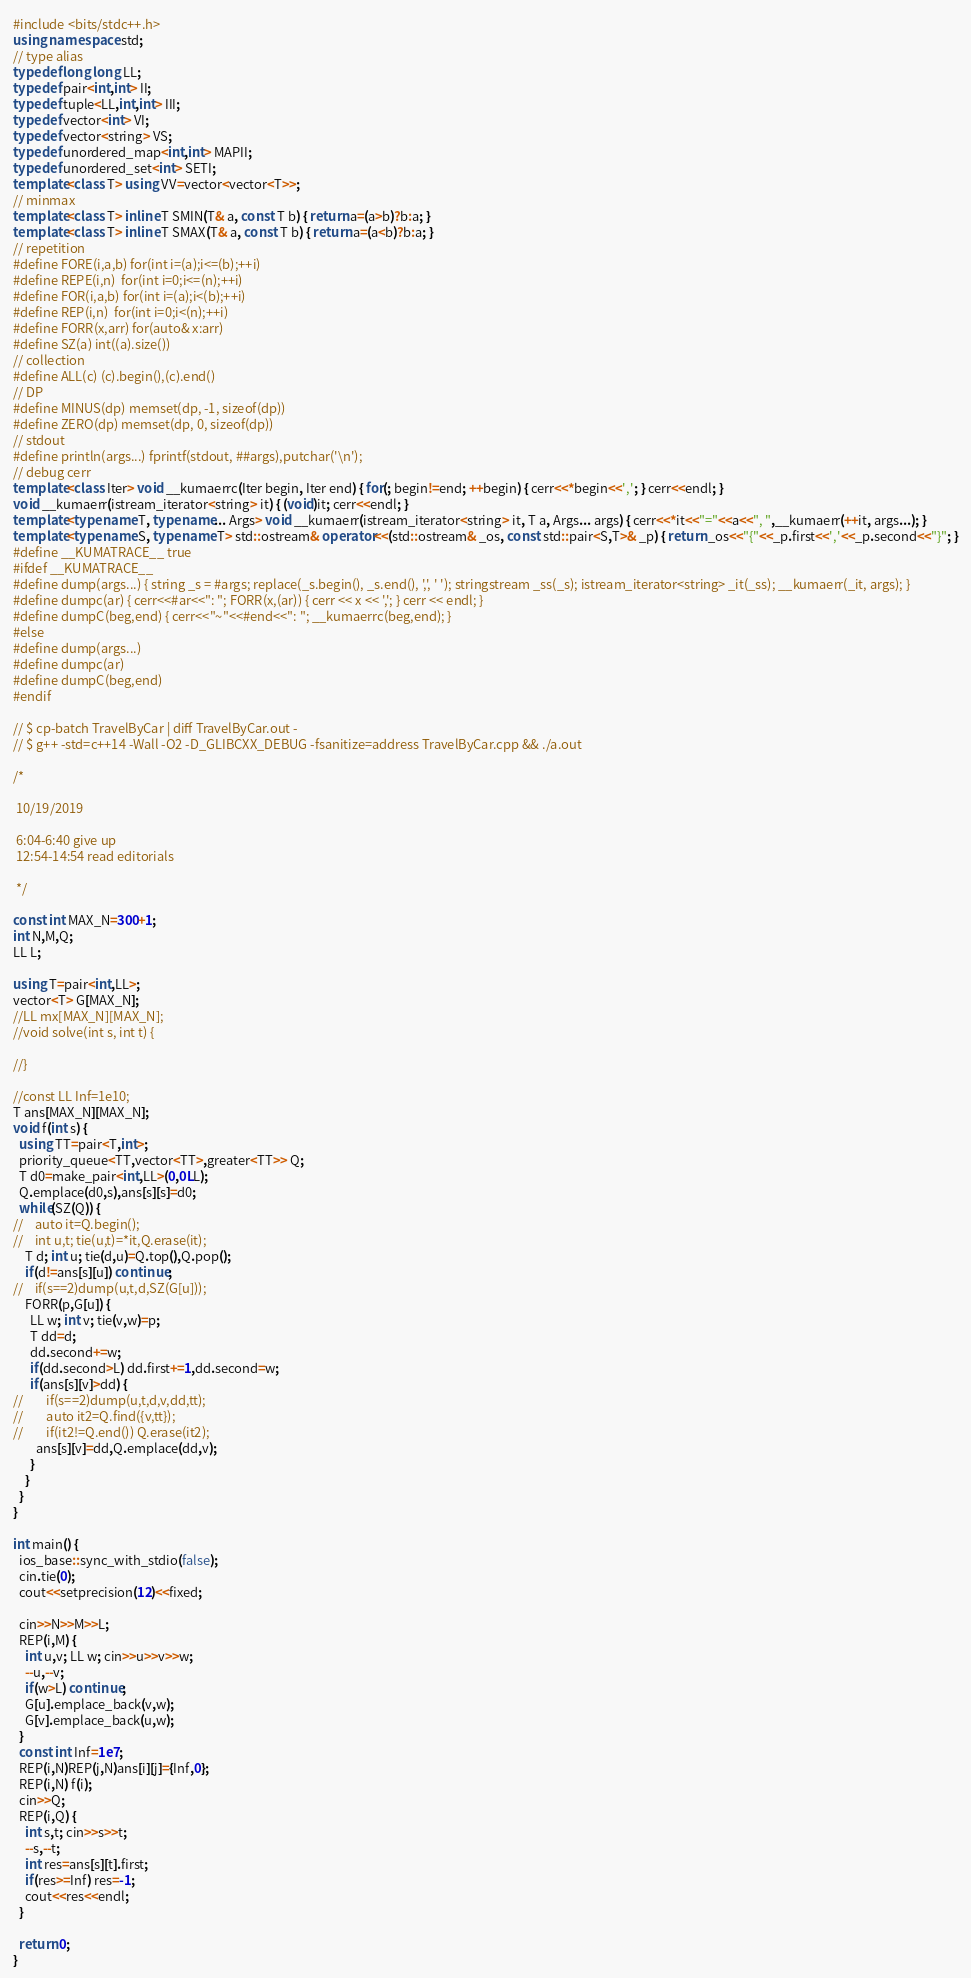<code> <loc_0><loc_0><loc_500><loc_500><_C++_>#include <bits/stdc++.h>
using namespace std;
// type alias
typedef long long LL;
typedef pair<int,int> II;
typedef tuple<LL,int,int> III;
typedef vector<int> VI;
typedef vector<string> VS;
typedef unordered_map<int,int> MAPII;
typedef unordered_set<int> SETI;
template<class T> using VV=vector<vector<T>>;
// minmax
template<class T> inline T SMIN(T& a, const T b) { return a=(a>b)?b:a; }
template<class T> inline T SMAX(T& a, const T b) { return a=(a<b)?b:a; }
// repetition
#define FORE(i,a,b) for(int i=(a);i<=(b);++i)
#define REPE(i,n)  for(int i=0;i<=(n);++i)
#define FOR(i,a,b) for(int i=(a);i<(b);++i)
#define REP(i,n)  for(int i=0;i<(n);++i)
#define FORR(x,arr) for(auto& x:arr)
#define SZ(a) int((a).size())
// collection
#define ALL(c) (c).begin(),(c).end()
// DP
#define MINUS(dp) memset(dp, -1, sizeof(dp))
#define ZERO(dp) memset(dp, 0, sizeof(dp))
// stdout
#define println(args...) fprintf(stdout, ##args),putchar('\n');
// debug cerr
template<class Iter> void __kumaerrc(Iter begin, Iter end) { for(; begin!=end; ++begin) { cerr<<*begin<<','; } cerr<<endl; }
void __kumaerr(istream_iterator<string> it) { (void)it; cerr<<endl; }
template<typename T, typename... Args> void __kumaerr(istream_iterator<string> it, T a, Args... args) { cerr<<*it<<"="<<a<<", ",__kumaerr(++it, args...); }
template<typename S, typename T> std::ostream& operator<<(std::ostream& _os, const std::pair<S,T>& _p) { return _os<<"{"<<_p.first<<','<<_p.second<<"}"; }
#define __KUMATRACE__ true
#ifdef __KUMATRACE__
#define dump(args...) { string _s = #args; replace(_s.begin(), _s.end(), ',', ' '); stringstream _ss(_s); istream_iterator<string> _it(_ss); __kumaerr(_it, args); }
#define dumpc(ar) { cerr<<#ar<<": "; FORR(x,(ar)) { cerr << x << ','; } cerr << endl; }
#define dumpC(beg,end) { cerr<<"~"<<#end<<": "; __kumaerrc(beg,end); }
#else
#define dump(args...)
#define dumpc(ar)
#define dumpC(beg,end)
#endif

// $ cp-batch TravelByCar | diff TravelByCar.out -
// $ g++ -std=c++14 -Wall -O2 -D_GLIBCXX_DEBUG -fsanitize=address TravelByCar.cpp && ./a.out

/*
 
 10/19/2019
 
 6:04-6:40 give up
 12:54-14:54 read editorials
 
 */

const int MAX_N=300+1;
int N,M,Q;
LL L;

using T=pair<int,LL>;
vector<T> G[MAX_N];
//LL mx[MAX_N][MAX_N];
//void solve(int s, int t) {
  
//}

//const LL Inf=1e10;
T ans[MAX_N][MAX_N];
void f(int s) {
  using TT=pair<T,int>;
  priority_queue<TT,vector<TT>,greater<TT>> Q;
  T d0=make_pair<int,LL>(0,0LL);
  Q.emplace(d0,s),ans[s][s]=d0;
  while(SZ(Q)) {
//    auto it=Q.begin();
//    int u,t; tie(u,t)=*it,Q.erase(it);
    T d; int u; tie(d,u)=Q.top(),Q.pop();
    if(d!=ans[s][u]) continue;
//    if(s==2)dump(u,t,d,SZ(G[u]));
    FORR(p,G[u]) {
      LL w; int v; tie(v,w)=p;
      T dd=d;
      dd.second+=w;
      if(dd.second>L) dd.first+=1,dd.second=w;
      if(ans[s][v]>dd) {
//        if(s==2)dump(u,t,d,v,dd,tt);
//        auto it2=Q.find({v,tt});
//        if(it2!=Q.end()) Q.erase(it2);
        ans[s][v]=dd,Q.emplace(dd,v);
      }
    }
  }
}

int main() {
  ios_base::sync_with_stdio(false);
  cin.tie(0);
  cout<<setprecision(12)<<fixed;
  
  cin>>N>>M>>L;
  REP(i,M) {
    int u,v; LL w; cin>>u>>v>>w;
    --u,--v;
    if(w>L) continue;
    G[u].emplace_back(v,w);
    G[v].emplace_back(u,w);
  }
  const int Inf=1e7;
  REP(i,N)REP(j,N)ans[i][j]={Inf,0};
  REP(i,N) f(i);
  cin>>Q;
  REP(i,Q) {
    int s,t; cin>>s>>t;
    --s,--t;
    int res=ans[s][t].first;
    if(res>=Inf) res=-1;
    cout<<res<<endl;
  }
  
  return 0;
}
</code> 